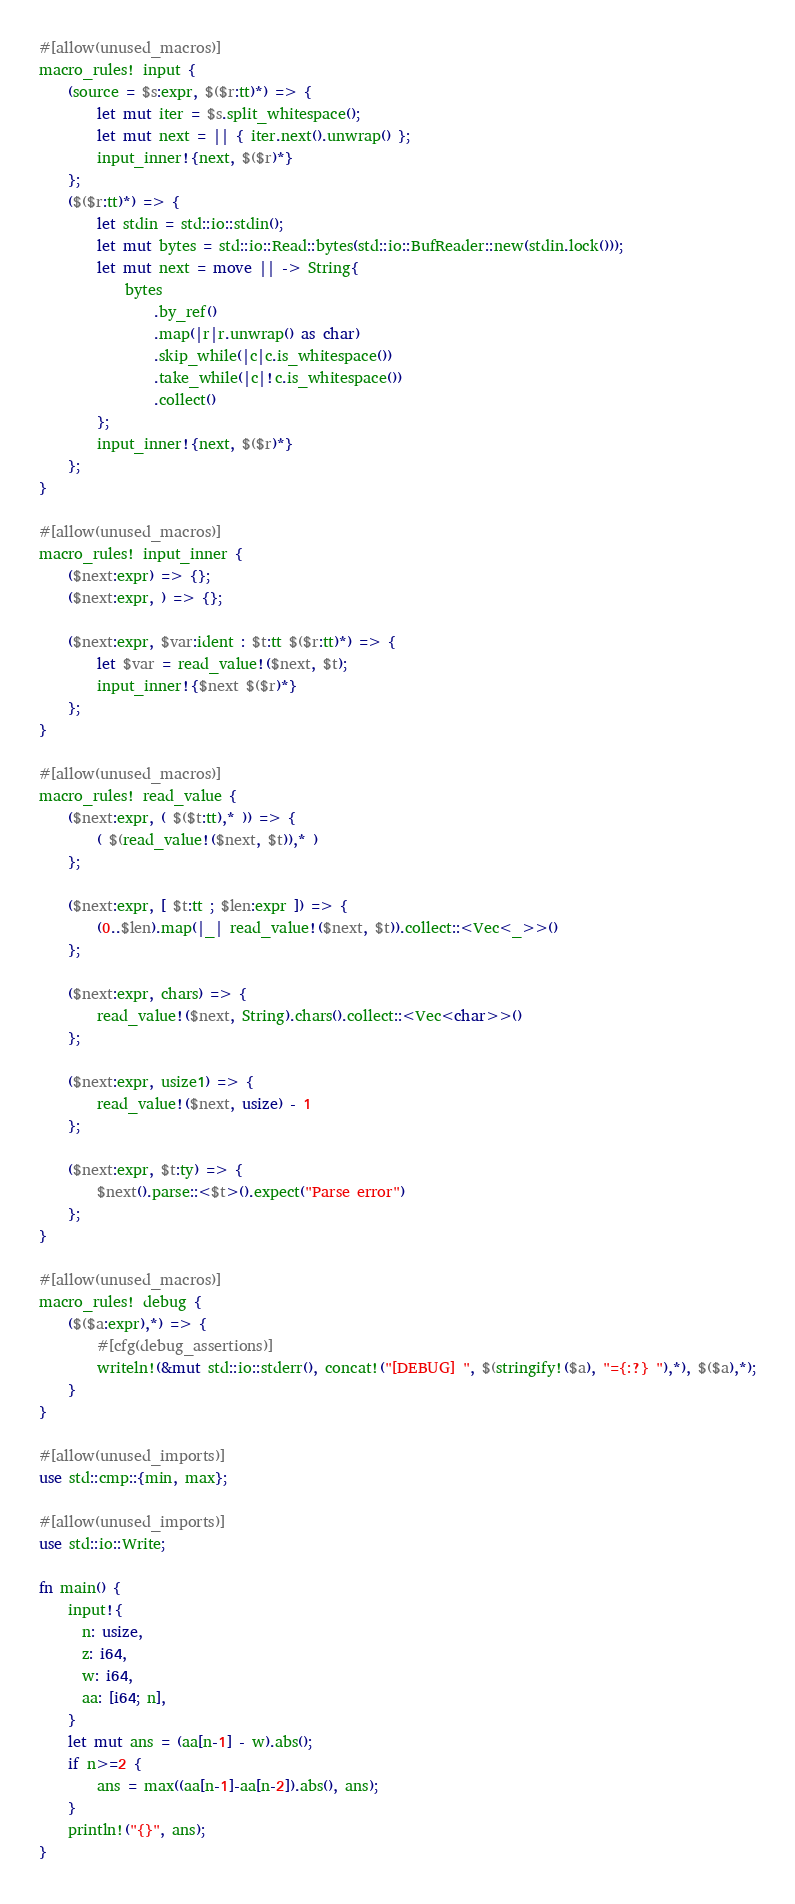<code> <loc_0><loc_0><loc_500><loc_500><_Rust_>#[allow(unused_macros)]
macro_rules! input {
    (source = $s:expr, $($r:tt)*) => {
        let mut iter = $s.split_whitespace();
        let mut next = || { iter.next().unwrap() };
        input_inner!{next, $($r)*}
    };
    ($($r:tt)*) => {
        let stdin = std::io::stdin();
        let mut bytes = std::io::Read::bytes(std::io::BufReader::new(stdin.lock()));
        let mut next = move || -> String{
            bytes
                .by_ref()
                .map(|r|r.unwrap() as char)
                .skip_while(|c|c.is_whitespace())
                .take_while(|c|!c.is_whitespace())
                .collect()
        };
        input_inner!{next, $($r)*}
    };
}

#[allow(unused_macros)]
macro_rules! input_inner {
    ($next:expr) => {};
    ($next:expr, ) => {};

    ($next:expr, $var:ident : $t:tt $($r:tt)*) => {
        let $var = read_value!($next, $t);
        input_inner!{$next $($r)*}
    };
}

#[allow(unused_macros)]
macro_rules! read_value {
    ($next:expr, ( $($t:tt),* )) => {
        ( $(read_value!($next, $t)),* )
    };

    ($next:expr, [ $t:tt ; $len:expr ]) => {
        (0..$len).map(|_| read_value!($next, $t)).collect::<Vec<_>>()
    };

    ($next:expr, chars) => {
        read_value!($next, String).chars().collect::<Vec<char>>()
    };

    ($next:expr, usize1) => {
        read_value!($next, usize) - 1
    };

    ($next:expr, $t:ty) => {
        $next().parse::<$t>().expect("Parse error")
    };
}

#[allow(unused_macros)]
macro_rules! debug {
    ($($a:expr),*) => {
        #[cfg(debug_assertions)]
        writeln!(&mut std::io::stderr(), concat!("[DEBUG] ", $(stringify!($a), "={:?} "),*), $($a),*);
    }
}

#[allow(unused_imports)]
use std::cmp::{min, max};

#[allow(unused_imports)]
use std::io::Write;

fn main() {
    input!{
      n: usize,
      z: i64,
      w: i64,
      aa: [i64; n],
    }
    let mut ans = (aa[n-1] - w).abs();
    if n>=2 {
        ans = max((aa[n-1]-aa[n-2]).abs(), ans);
    }
    println!("{}", ans);
}
</code> 